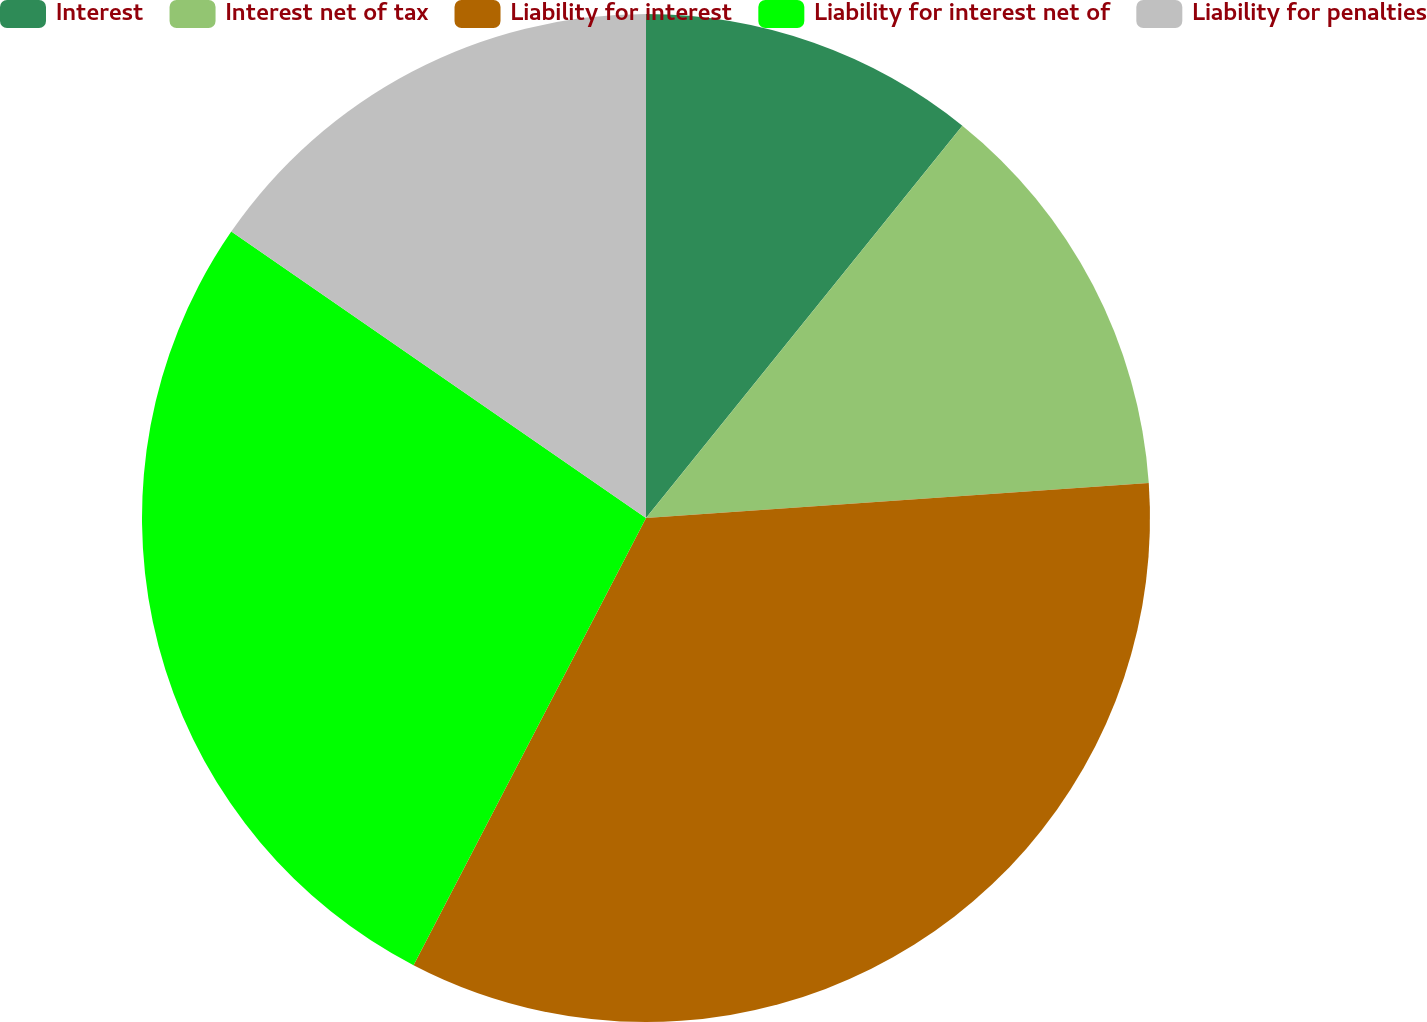Convert chart to OTSL. <chart><loc_0><loc_0><loc_500><loc_500><pie_chart><fcel>Interest<fcel>Interest net of tax<fcel>Liability for interest<fcel>Liability for interest net of<fcel>Liability for penalties<nl><fcel>10.8%<fcel>13.09%<fcel>33.74%<fcel>26.99%<fcel>15.38%<nl></chart> 